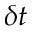Convert formula to latex. <formula><loc_0><loc_0><loc_500><loc_500>\delta t</formula> 